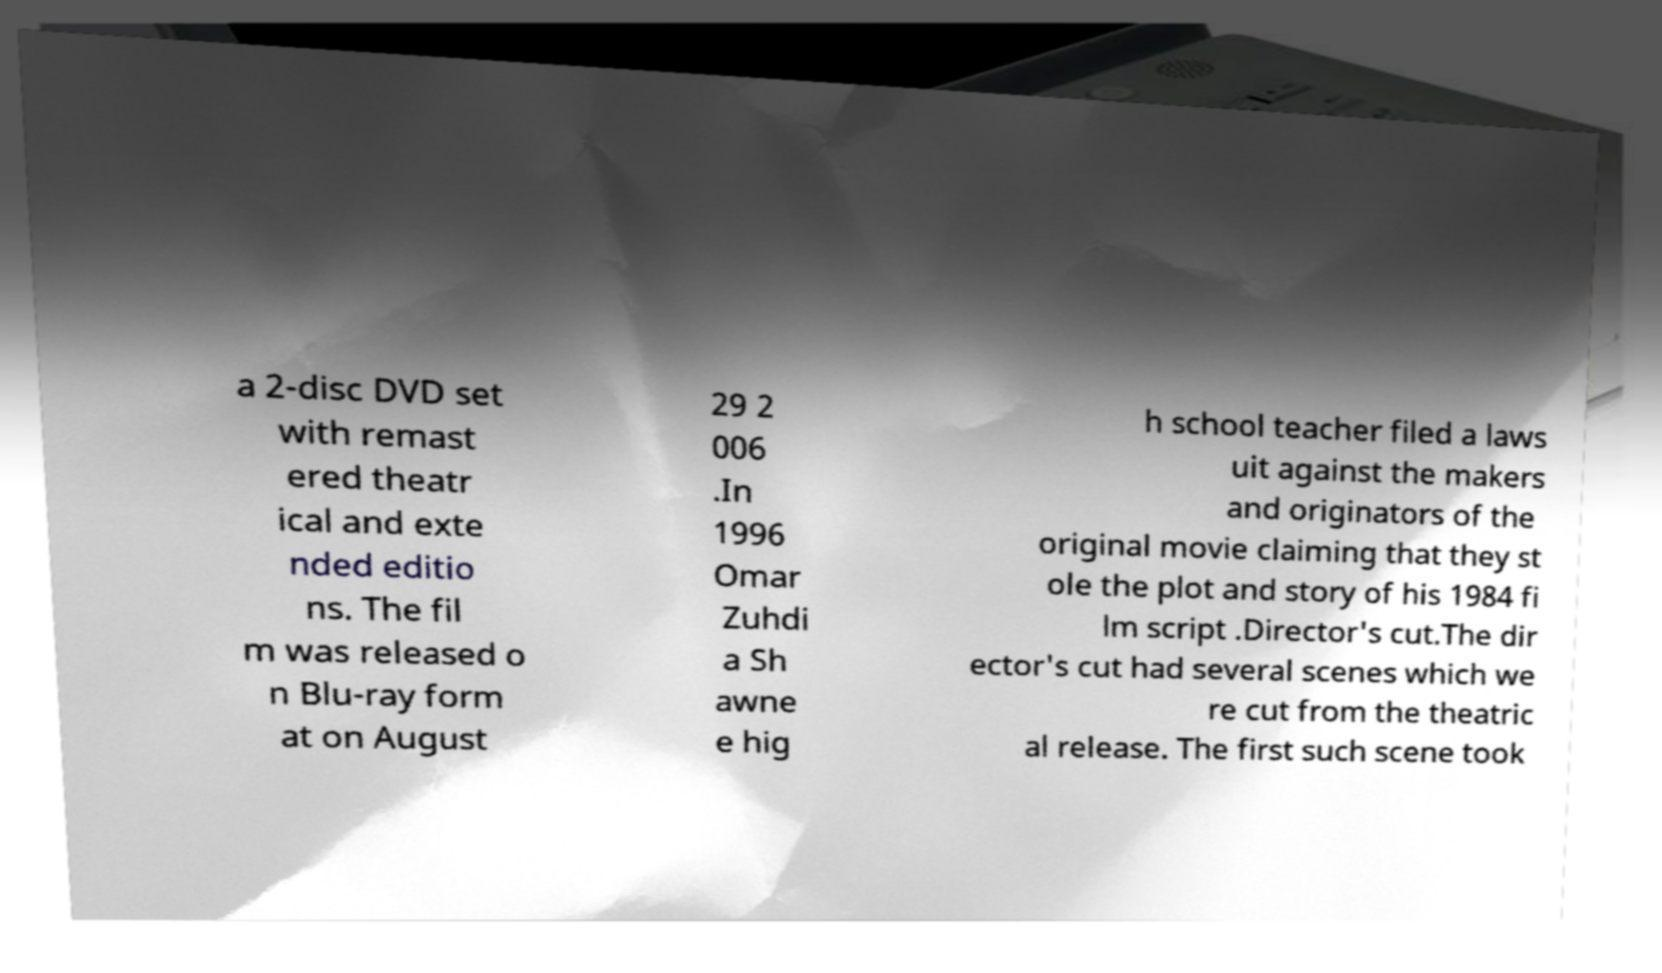Please identify and transcribe the text found in this image. a 2-disc DVD set with remast ered theatr ical and exte nded editio ns. The fil m was released o n Blu-ray form at on August 29 2 006 .In 1996 Omar Zuhdi a Sh awne e hig h school teacher filed a laws uit against the makers and originators of the original movie claiming that they st ole the plot and story of his 1984 fi lm script .Director's cut.The dir ector's cut had several scenes which we re cut from the theatric al release. The first such scene took 